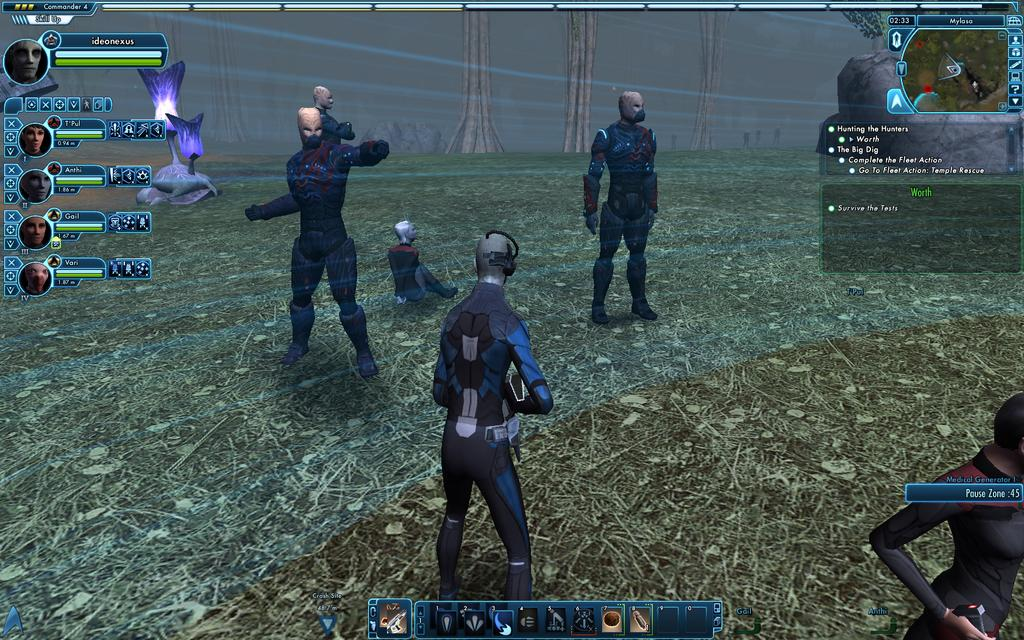What type of image is being described? The image is graphical. What does the image resemble? The image resembles a video game. What is the aftermath of the whip in the image? There is no whip present in the image, and therefore no aftermath to discuss. 